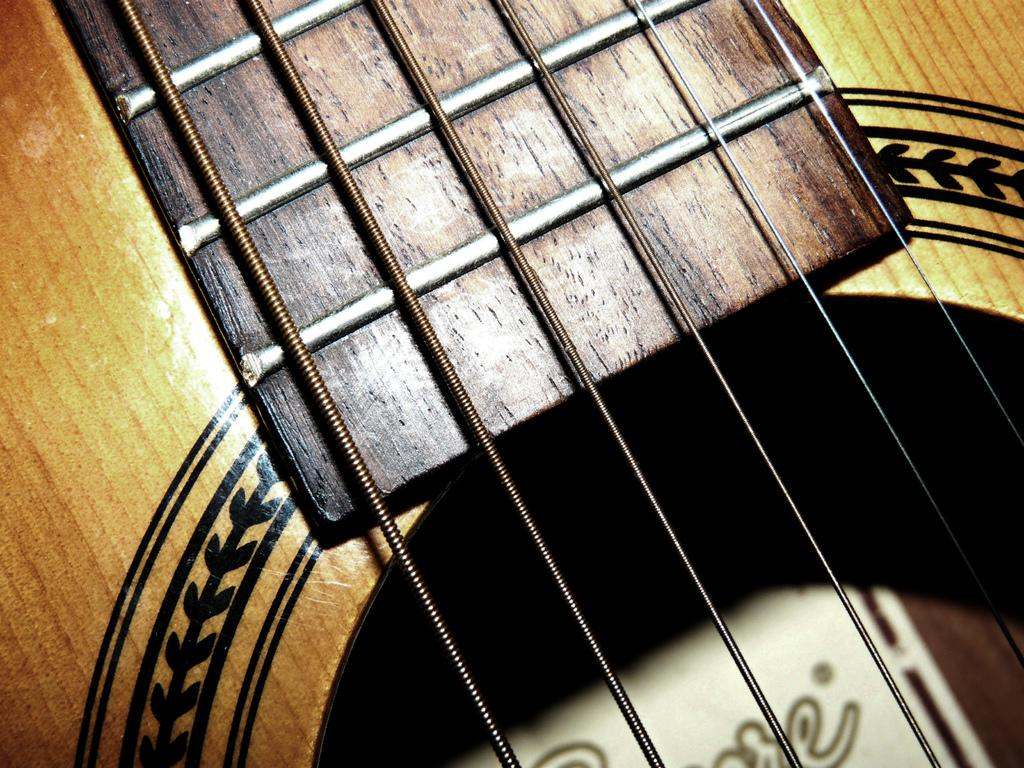What type of object is present in the image that is related to music? There is a musical instrument in the image. Can you describe the musical instrument in more detail? The musical instrument has multiple strings. Where is the friend sitting on the tramp in the image? There is no friend or tramp present in the image; it only features a musical instrument with multiple strings. 